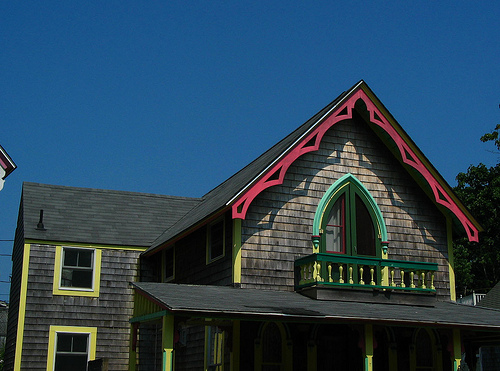<image>
Can you confirm if the sky is next to the house? No. The sky is not positioned next to the house. They are located in different areas of the scene. 